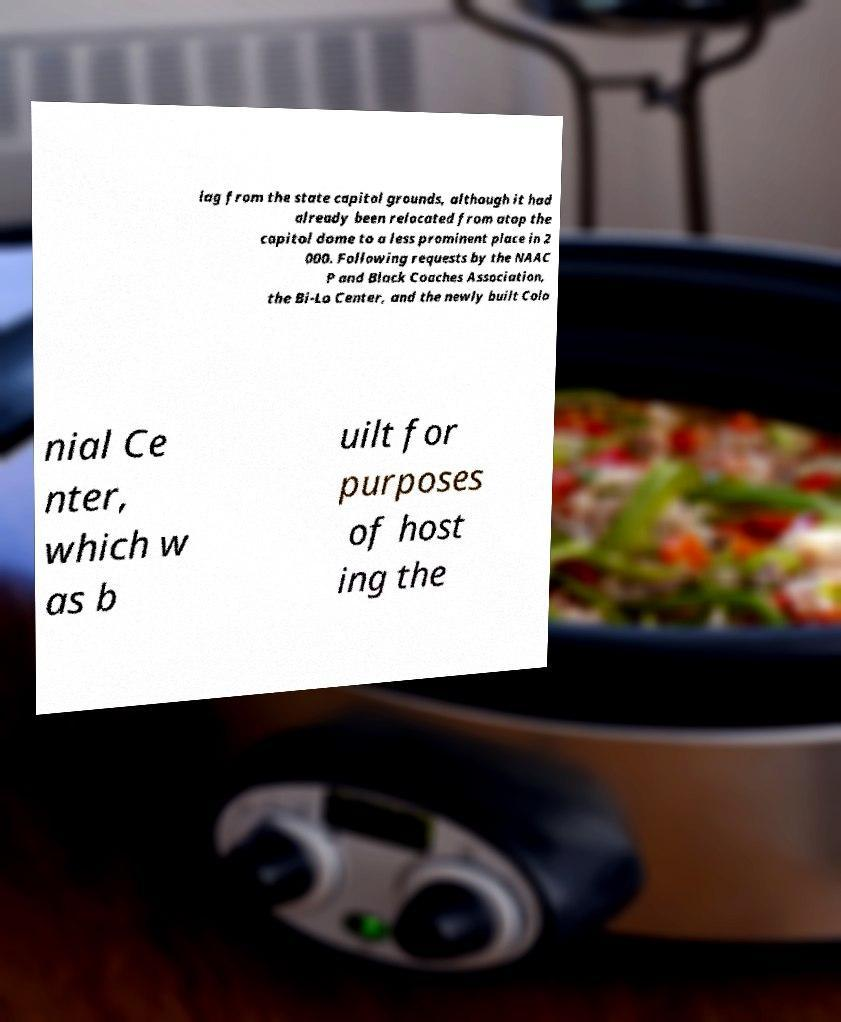Can you read and provide the text displayed in the image?This photo seems to have some interesting text. Can you extract and type it out for me? lag from the state capitol grounds, although it had already been relocated from atop the capitol dome to a less prominent place in 2 000. Following requests by the NAAC P and Black Coaches Association, the Bi-Lo Center, and the newly built Colo nial Ce nter, which w as b uilt for purposes of host ing the 